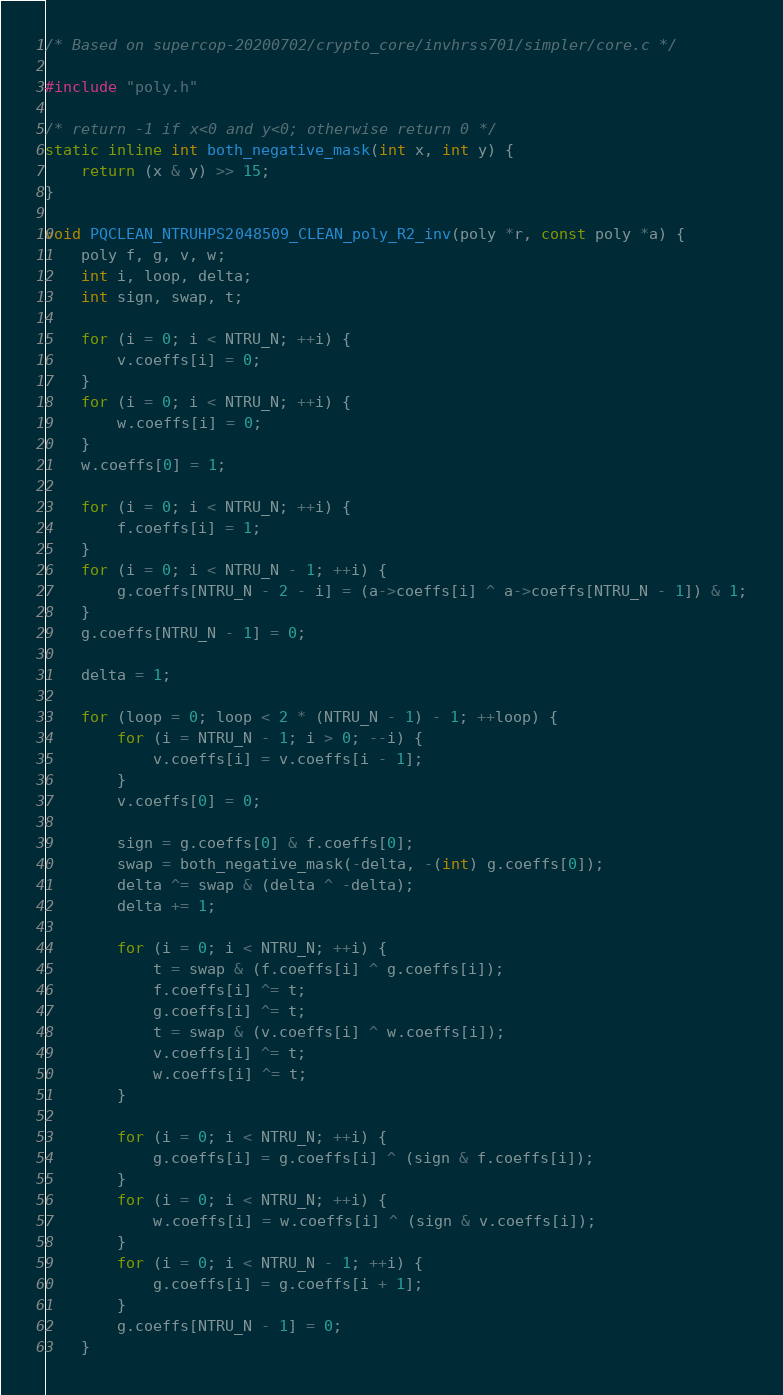<code> <loc_0><loc_0><loc_500><loc_500><_C_>/* Based on supercop-20200702/crypto_core/invhrss701/simpler/core.c */

#include "poly.h"

/* return -1 if x<0 and y<0; otherwise return 0 */
static inline int both_negative_mask(int x, int y) {
    return (x & y) >> 15;
}

void PQCLEAN_NTRUHPS2048509_CLEAN_poly_R2_inv(poly *r, const poly *a) {
    poly f, g, v, w;
    int i, loop, delta;
    int sign, swap, t;

    for (i = 0; i < NTRU_N; ++i) {
        v.coeffs[i] = 0;
    }
    for (i = 0; i < NTRU_N; ++i) {
        w.coeffs[i] = 0;
    }
    w.coeffs[0] = 1;

    for (i = 0; i < NTRU_N; ++i) {
        f.coeffs[i] = 1;
    }
    for (i = 0; i < NTRU_N - 1; ++i) {
        g.coeffs[NTRU_N - 2 - i] = (a->coeffs[i] ^ a->coeffs[NTRU_N - 1]) & 1;
    }
    g.coeffs[NTRU_N - 1] = 0;

    delta = 1;

    for (loop = 0; loop < 2 * (NTRU_N - 1) - 1; ++loop) {
        for (i = NTRU_N - 1; i > 0; --i) {
            v.coeffs[i] = v.coeffs[i - 1];
        }
        v.coeffs[0] = 0;

        sign = g.coeffs[0] & f.coeffs[0];
        swap = both_negative_mask(-delta, -(int) g.coeffs[0]);
        delta ^= swap & (delta ^ -delta);
        delta += 1;

        for (i = 0; i < NTRU_N; ++i) {
            t = swap & (f.coeffs[i] ^ g.coeffs[i]);
            f.coeffs[i] ^= t;
            g.coeffs[i] ^= t;
            t = swap & (v.coeffs[i] ^ w.coeffs[i]);
            v.coeffs[i] ^= t;
            w.coeffs[i] ^= t;
        }

        for (i = 0; i < NTRU_N; ++i) {
            g.coeffs[i] = g.coeffs[i] ^ (sign & f.coeffs[i]);
        }
        for (i = 0; i < NTRU_N; ++i) {
            w.coeffs[i] = w.coeffs[i] ^ (sign & v.coeffs[i]);
        }
        for (i = 0; i < NTRU_N - 1; ++i) {
            g.coeffs[i] = g.coeffs[i + 1];
        }
        g.coeffs[NTRU_N - 1] = 0;
    }
</code> 